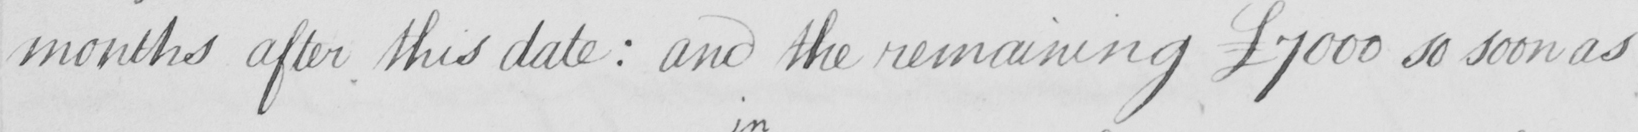Please provide the text content of this handwritten line. months after this date :  and the remaining £7000 so soon as 